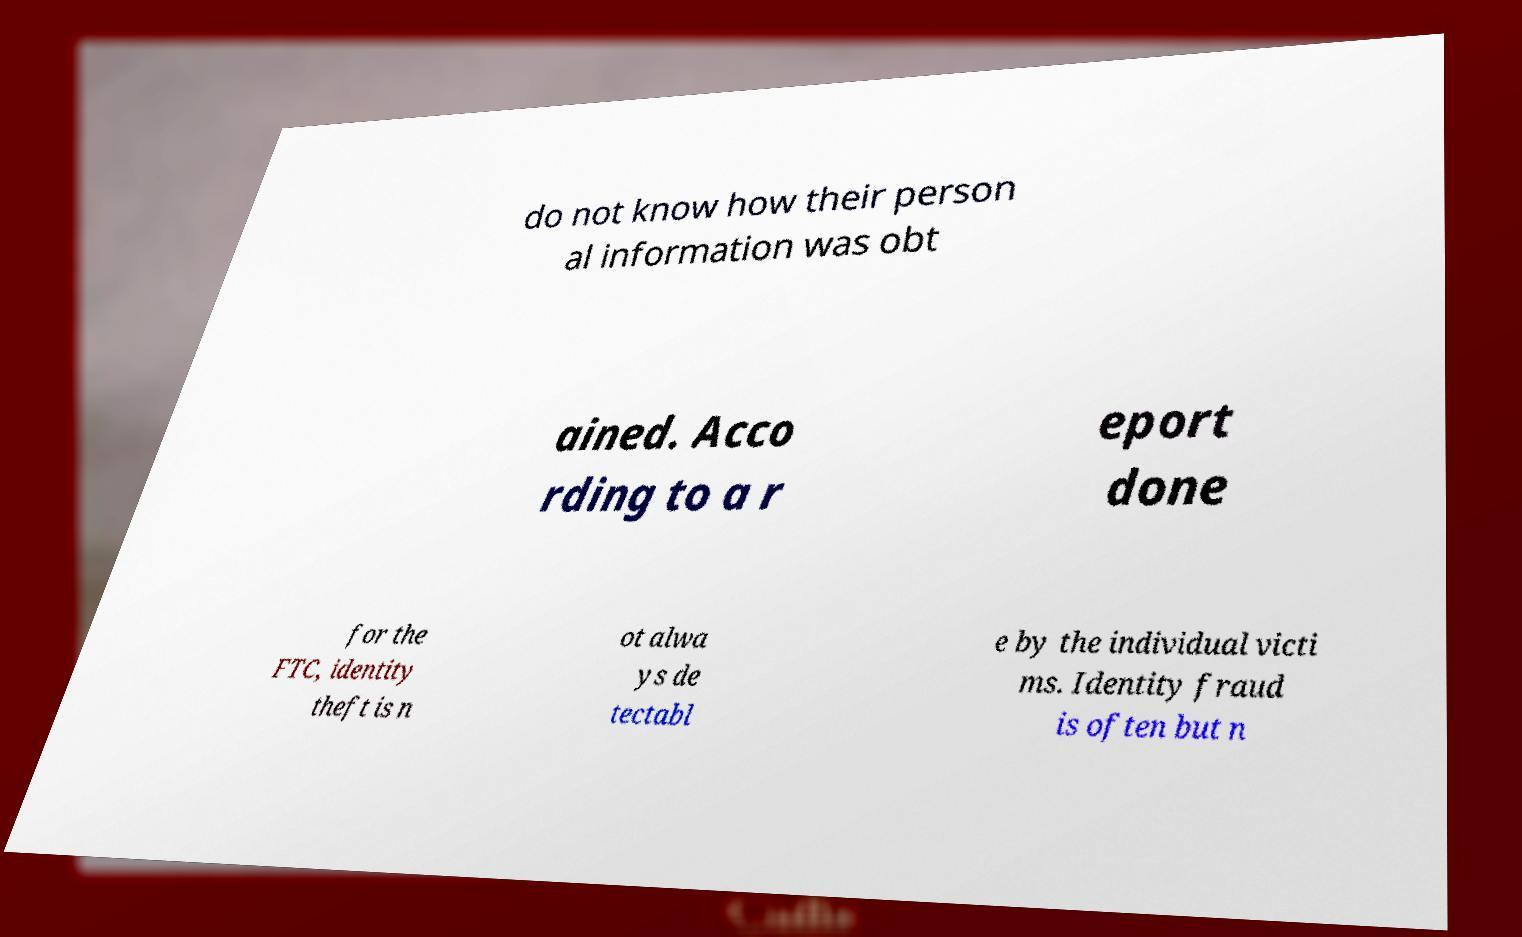There's text embedded in this image that I need extracted. Can you transcribe it verbatim? do not know how their person al information was obt ained. Acco rding to a r eport done for the FTC, identity theft is n ot alwa ys de tectabl e by the individual victi ms. Identity fraud is often but n 